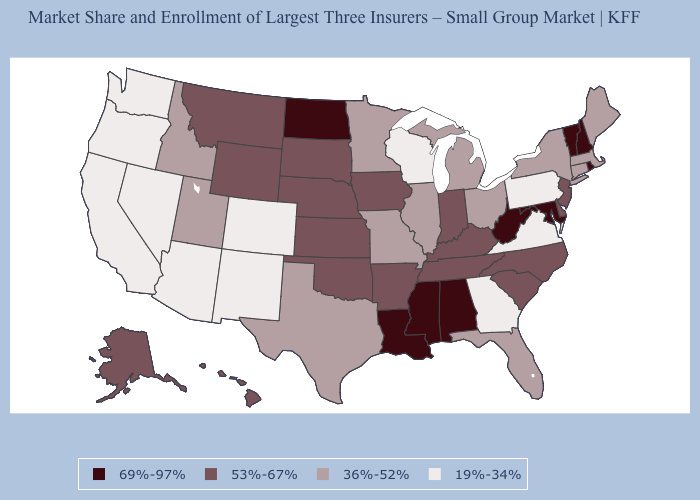Name the states that have a value in the range 53%-67%?
Answer briefly. Alaska, Arkansas, Delaware, Hawaii, Indiana, Iowa, Kansas, Kentucky, Montana, Nebraska, New Jersey, North Carolina, Oklahoma, South Carolina, South Dakota, Tennessee, Wyoming. What is the highest value in the USA?
Give a very brief answer. 69%-97%. Which states have the lowest value in the MidWest?
Quick response, please. Wisconsin. What is the value of Illinois?
Keep it brief. 36%-52%. Among the states that border Georgia , which have the highest value?
Give a very brief answer. Alabama. What is the value of Colorado?
Short answer required. 19%-34%. Name the states that have a value in the range 19%-34%?
Keep it brief. Arizona, California, Colorado, Georgia, Nevada, New Mexico, Oregon, Pennsylvania, Virginia, Washington, Wisconsin. Name the states that have a value in the range 69%-97%?
Answer briefly. Alabama, Louisiana, Maryland, Mississippi, New Hampshire, North Dakota, Rhode Island, Vermont, West Virginia. What is the lowest value in the USA?
Concise answer only. 19%-34%. Name the states that have a value in the range 36%-52%?
Short answer required. Connecticut, Florida, Idaho, Illinois, Maine, Massachusetts, Michigan, Minnesota, Missouri, New York, Ohio, Texas, Utah. What is the highest value in the USA?
Be succinct. 69%-97%. Does the map have missing data?
Short answer required. No. What is the highest value in the MidWest ?
Concise answer only. 69%-97%. What is the lowest value in states that border New Mexico?
Quick response, please. 19%-34%. Does the map have missing data?
Quick response, please. No. 